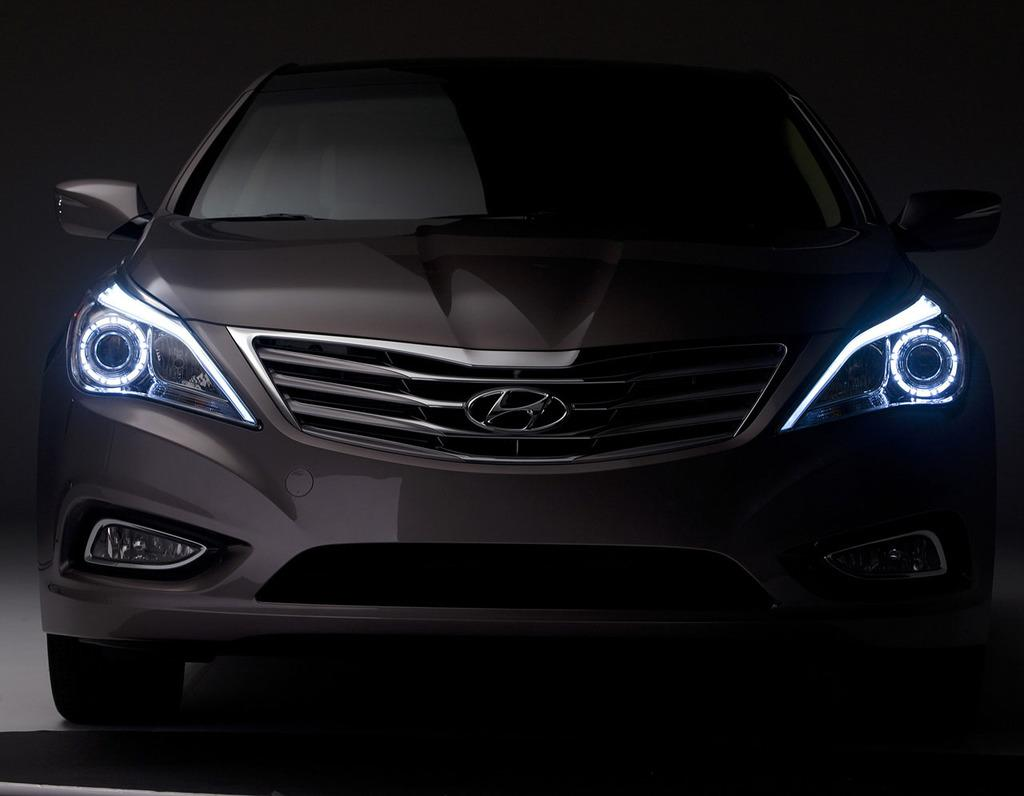What is the main subject of the image? There is a car in the image. Where is the car located in the image? The car is on the floor. Can you describe the lighting conditions in the image? The image was clicked in the dark. What type of locket can be seen hanging from the car's rearview mirror in the image? There is no locket present in the image; it only features a car on the floor in the dark. How do the people in the image react to the sudden thunder in the background? There is no mention of people or thunder in the image; it only shows a car on the floor in the dark. 